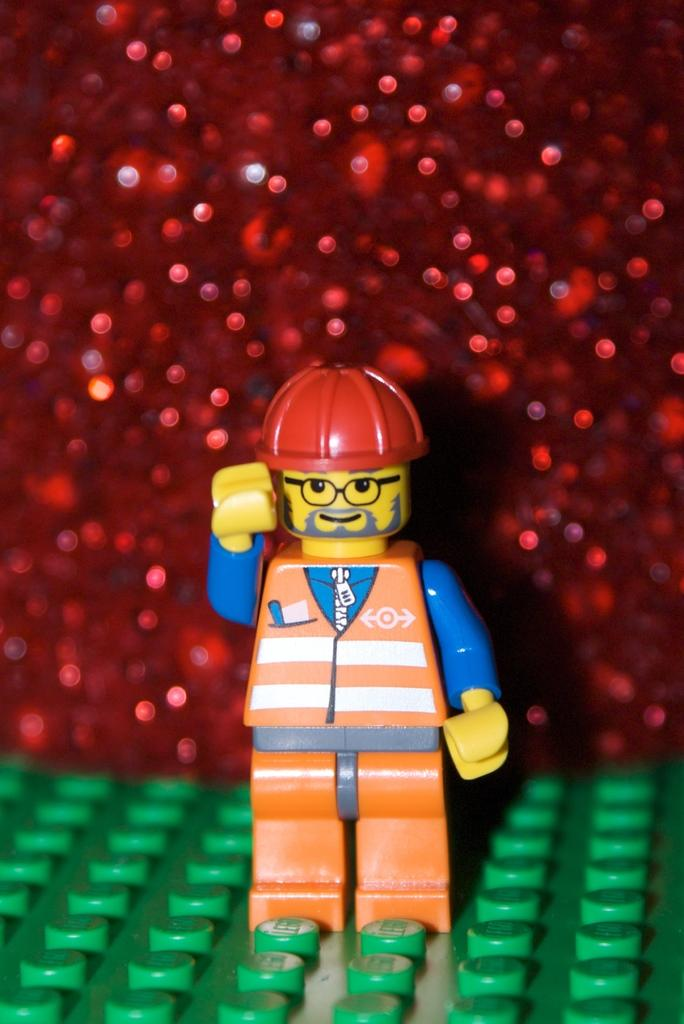What is the main subject in the center of the image? There is a toy in the center of the image. What can be found at the bottom of the image? There are legos at the bottom of the image. Can you describe the red-colored object in the background? Unfortunately, the facts provided do not give enough information to describe the red-colored object in the background. What type of yam is being played on the drum in the image? There is no drum or yam present in the image. What type of produce is being used to build the lego structure in the image? The facts provided do not mention any produce being used to build the lego structure. 